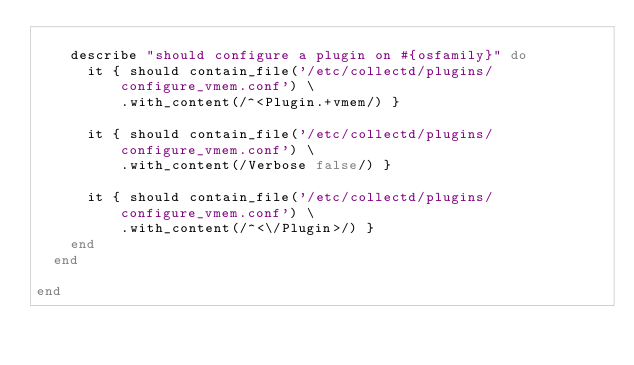<code> <loc_0><loc_0><loc_500><loc_500><_Ruby_>
    describe "should configure a plugin on #{osfamily}" do
      it { should contain_file('/etc/collectd/plugins/configure_vmem.conf') \
          .with_content(/^<Plugin.+vmem/) }

      it { should contain_file('/etc/collectd/plugins/configure_vmem.conf') \
          .with_content(/Verbose false/) }

      it { should contain_file('/etc/collectd/plugins/configure_vmem.conf') \
          .with_content(/^<\/Plugin>/) }
    end
  end

end
</code> 